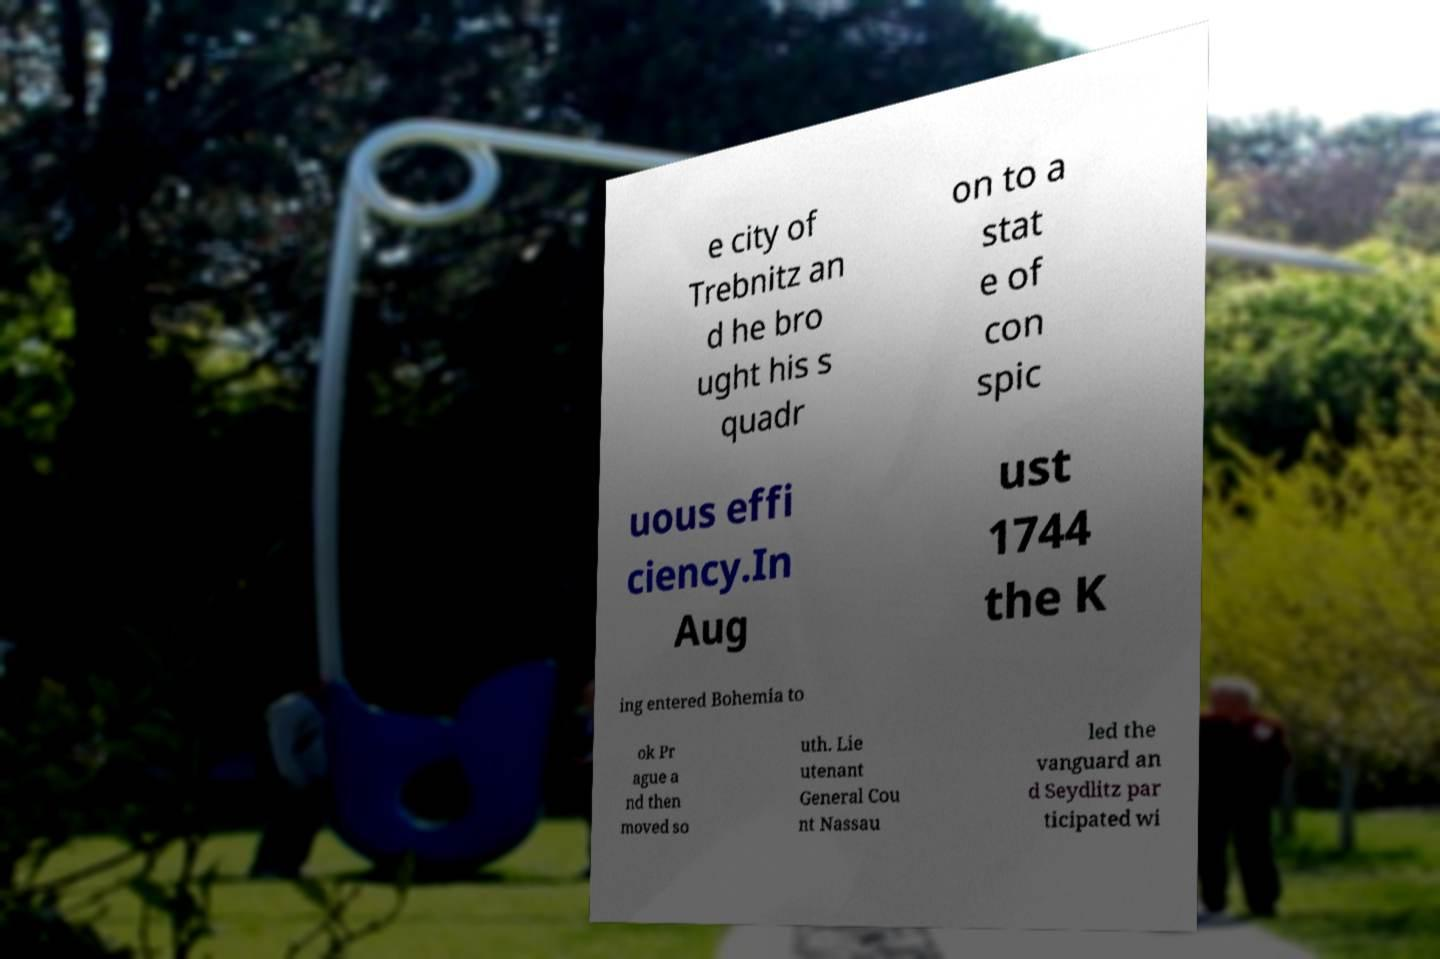There's text embedded in this image that I need extracted. Can you transcribe it verbatim? e city of Trebnitz an d he bro ught his s quadr on to a stat e of con spic uous effi ciency.In Aug ust 1744 the K ing entered Bohemia to ok Pr ague a nd then moved so uth. Lie utenant General Cou nt Nassau led the vanguard an d Seydlitz par ticipated wi 